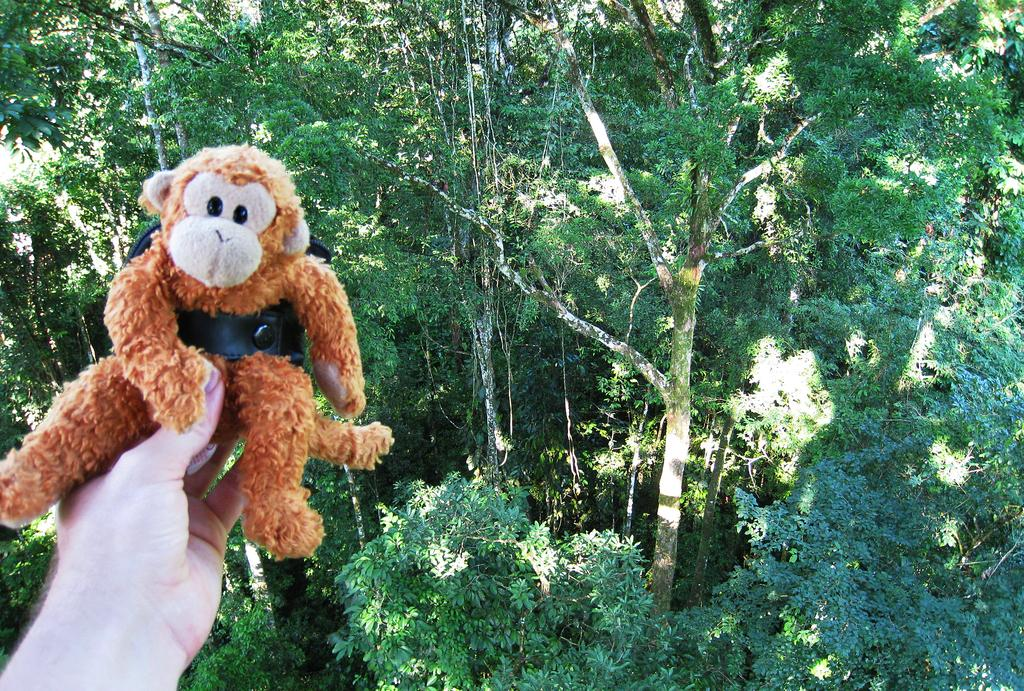What is the person holding in the image? The person is holding a brown color doll in their hand. What can be seen in the background of the image? There are trees in the background. What is the color of the leaves on the trees? The leaves on the trees are green. What type of shame can be seen on the doll's face in the image? There is no indication of shame on the doll's face in the image, as dolls do not have emotions. 